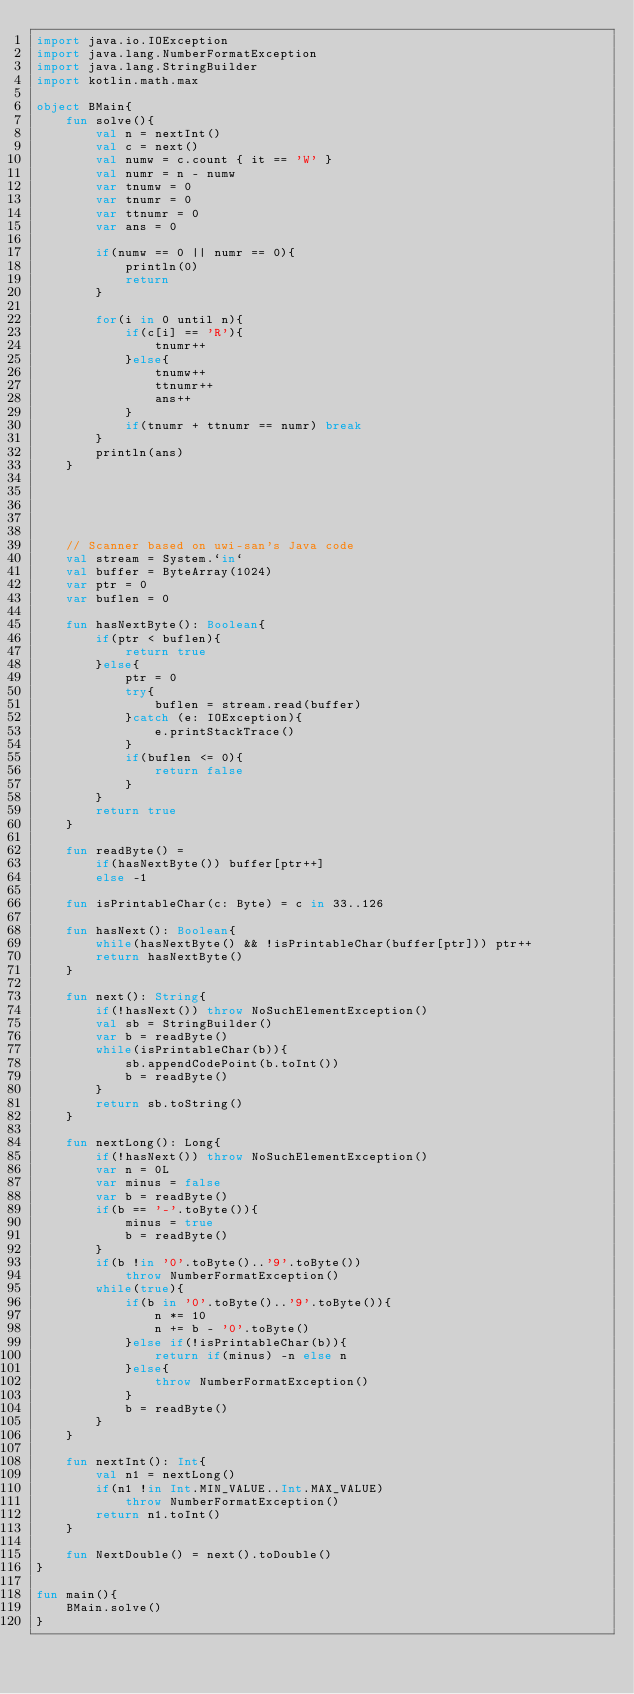<code> <loc_0><loc_0><loc_500><loc_500><_Kotlin_>import java.io.IOException
import java.lang.NumberFormatException
import java.lang.StringBuilder
import kotlin.math.max

object BMain{
    fun solve(){
        val n = nextInt()
        val c = next()
        val numw = c.count { it == 'W' }
        val numr = n - numw
        var tnumw = 0
        var tnumr = 0
        var ttnumr = 0
        var ans = 0

        if(numw == 0 || numr == 0){
            println(0)
            return
        }

        for(i in 0 until n){
            if(c[i] == 'R'){
                tnumr++
            }else{
                tnumw++
                ttnumr++
                ans++
            }
            if(tnumr + ttnumr == numr) break
        }
        println(ans)
    }





    // Scanner based on uwi-san's Java code
    val stream = System.`in`
    val buffer = ByteArray(1024)
    var ptr = 0
    var buflen = 0

    fun hasNextByte(): Boolean{
        if(ptr < buflen){
            return true
        }else{
            ptr = 0
            try{
                buflen = stream.read(buffer)
            }catch (e: IOException){
                e.printStackTrace()
            }
            if(buflen <= 0){
                return false
            }
        }
        return true
    }

    fun readByte() =
        if(hasNextByte()) buffer[ptr++]
        else -1

    fun isPrintableChar(c: Byte) = c in 33..126

    fun hasNext(): Boolean{
        while(hasNextByte() && !isPrintableChar(buffer[ptr])) ptr++
        return hasNextByte()
    }

    fun next(): String{
        if(!hasNext()) throw NoSuchElementException()
        val sb = StringBuilder()
        var b = readByte()
        while(isPrintableChar(b)){
            sb.appendCodePoint(b.toInt())
            b = readByte()
        }
        return sb.toString()
    }

    fun nextLong(): Long{
        if(!hasNext()) throw NoSuchElementException()
        var n = 0L
        var minus = false
        var b = readByte()
        if(b == '-'.toByte()){
            minus = true
            b = readByte()
        }
        if(b !in '0'.toByte()..'9'.toByte())
            throw NumberFormatException()
        while(true){
            if(b in '0'.toByte()..'9'.toByte()){
                n *= 10
                n += b - '0'.toByte()
            }else if(!isPrintableChar(b)){
                return if(minus) -n else n
            }else{
                throw NumberFormatException()
            }
            b = readByte()
        }
    }

    fun nextInt(): Int{
        val n1 = nextLong()
        if(n1 !in Int.MIN_VALUE..Int.MAX_VALUE)
            throw NumberFormatException()
        return n1.toInt()
    }

    fun NextDouble() = next().toDouble()
}

fun main(){
    BMain.solve()
}

</code> 